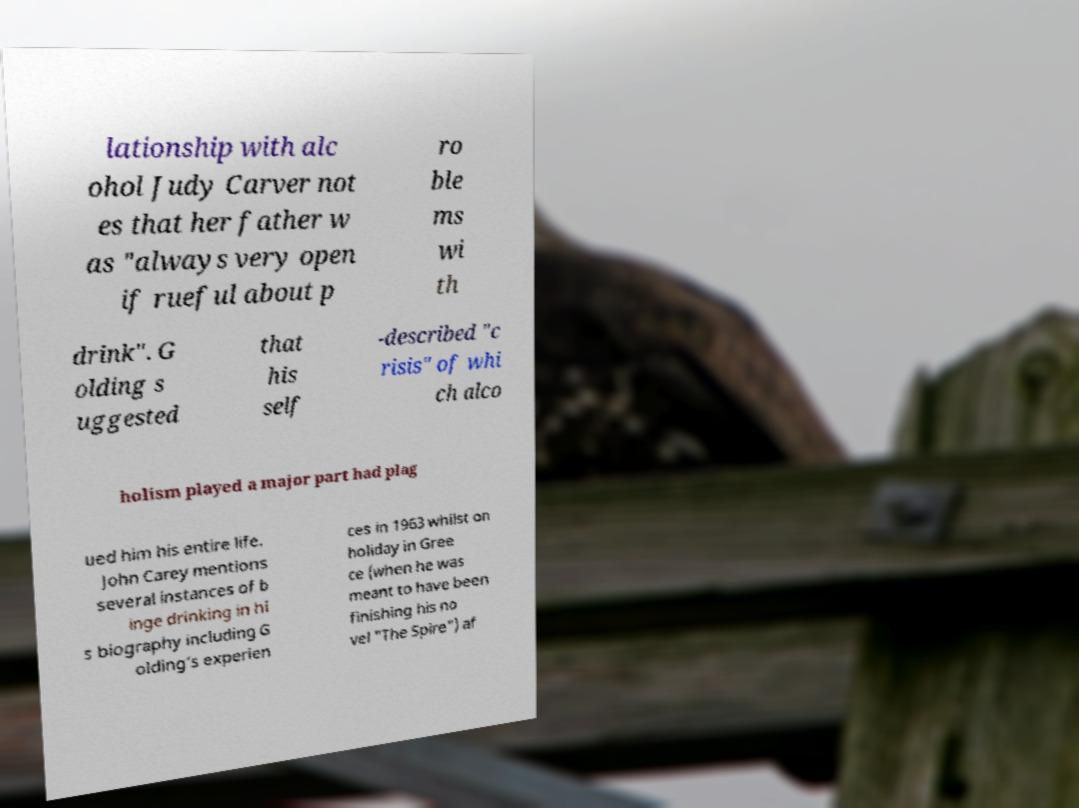Can you accurately transcribe the text from the provided image for me? lationship with alc ohol Judy Carver not es that her father w as "always very open if rueful about p ro ble ms wi th drink". G olding s uggested that his self -described "c risis" of whi ch alco holism played a major part had plag ued him his entire life. John Carey mentions several instances of b inge drinking in hi s biography including G olding’s experien ces in 1963 whilst on holiday in Gree ce (when he was meant to have been finishing his no vel "The Spire") af 